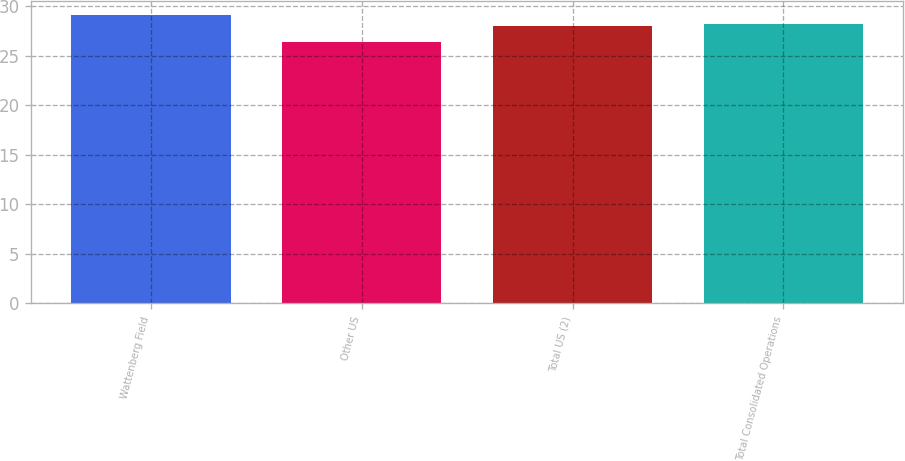Convert chart. <chart><loc_0><loc_0><loc_500><loc_500><bar_chart><fcel>Wattenberg Field<fcel>Other US<fcel>Total US (2)<fcel>Total Consolidated Operations<nl><fcel>29.1<fcel>26.37<fcel>27.96<fcel>28.23<nl></chart> 